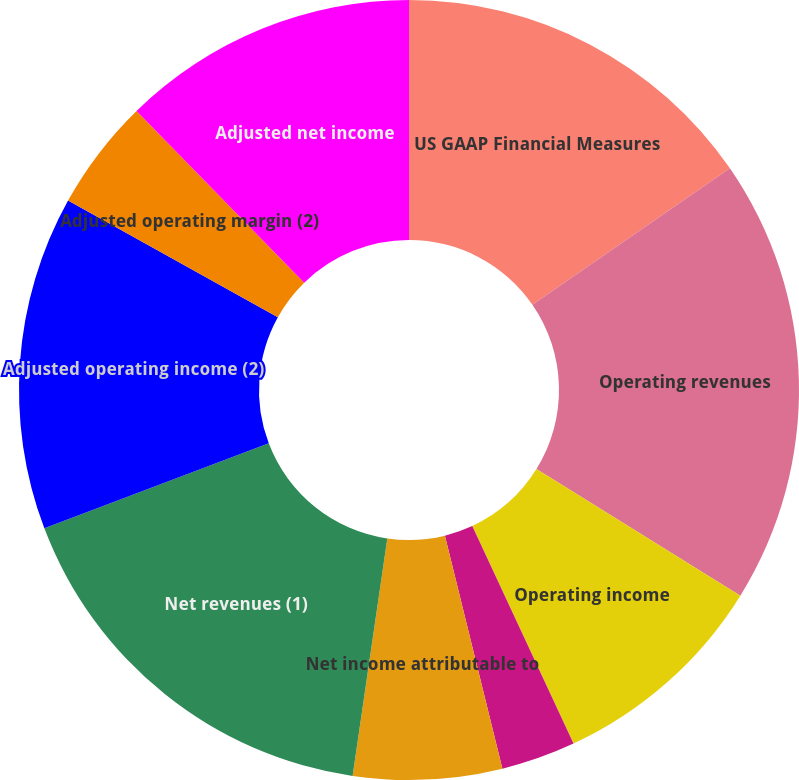Convert chart. <chart><loc_0><loc_0><loc_500><loc_500><pie_chart><fcel>US GAAP Financial Measures<fcel>Operating revenues<fcel>Operating income<fcel>Operating margin<fcel>Net income attributable to<fcel>Diluted EPS<fcel>Net revenues (1)<fcel>Adjusted operating income (2)<fcel>Adjusted operating margin (2)<fcel>Adjusted net income<nl><fcel>15.38%<fcel>18.46%<fcel>9.23%<fcel>3.08%<fcel>6.16%<fcel>0.0%<fcel>16.92%<fcel>13.84%<fcel>4.62%<fcel>12.31%<nl></chart> 